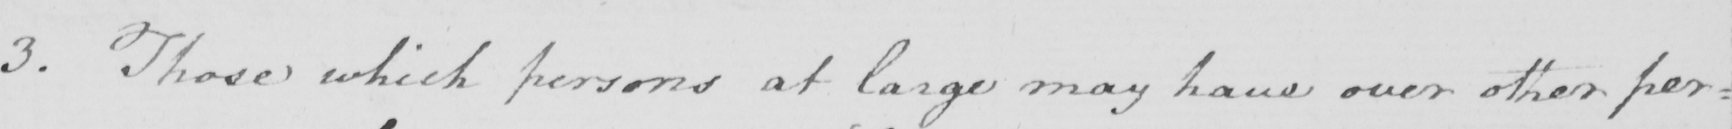Please provide the text content of this handwritten line. 3 . Those which persons at large may have over other per= 